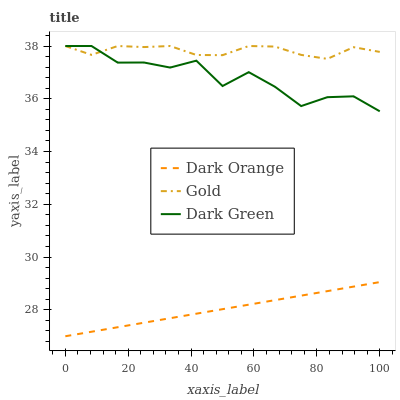Does Dark Green have the minimum area under the curve?
Answer yes or no. No. Does Dark Green have the maximum area under the curve?
Answer yes or no. No. Is Gold the smoothest?
Answer yes or no. No. Is Gold the roughest?
Answer yes or no. No. Does Dark Green have the lowest value?
Answer yes or no. No. Is Dark Orange less than Gold?
Answer yes or no. Yes. Is Dark Green greater than Dark Orange?
Answer yes or no. Yes. Does Dark Orange intersect Gold?
Answer yes or no. No. 